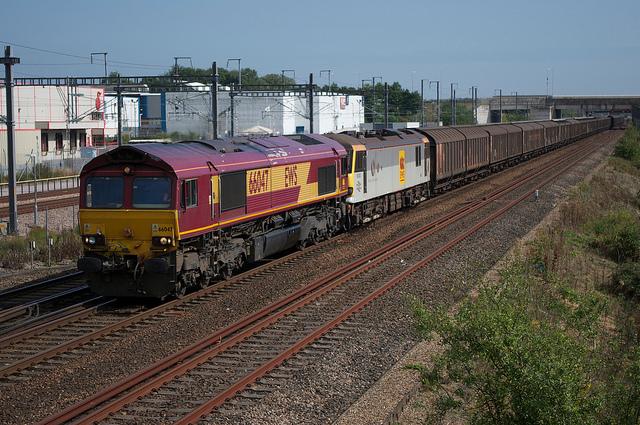What is the train tracks made of?
Answer briefly. Steel. What is the color of the train?
Keep it brief. Red and yellow. Is this a freight train?
Concise answer only. Yes. Is the train moving toward or away from us?
Give a very brief answer. Toward. What color is the last train car?
Be succinct. Brown. What color is the engine?
Concise answer only. Red. Is this a passenger train?
Quick response, please. No. How many tracks are there?
Short answer required. 2. Where is this train?
Write a very short answer. Tracks. How many cars on this train?
Concise answer only. 15. Is this train moving?
Answer briefly. Yes. How many trains can you see in the picture?
Concise answer only. 1. How many rail cars are there?
Keep it brief. 10. Is this day in the dead of winter?
Give a very brief answer. No. How many tracks are shown?
Give a very brief answer. 2. 